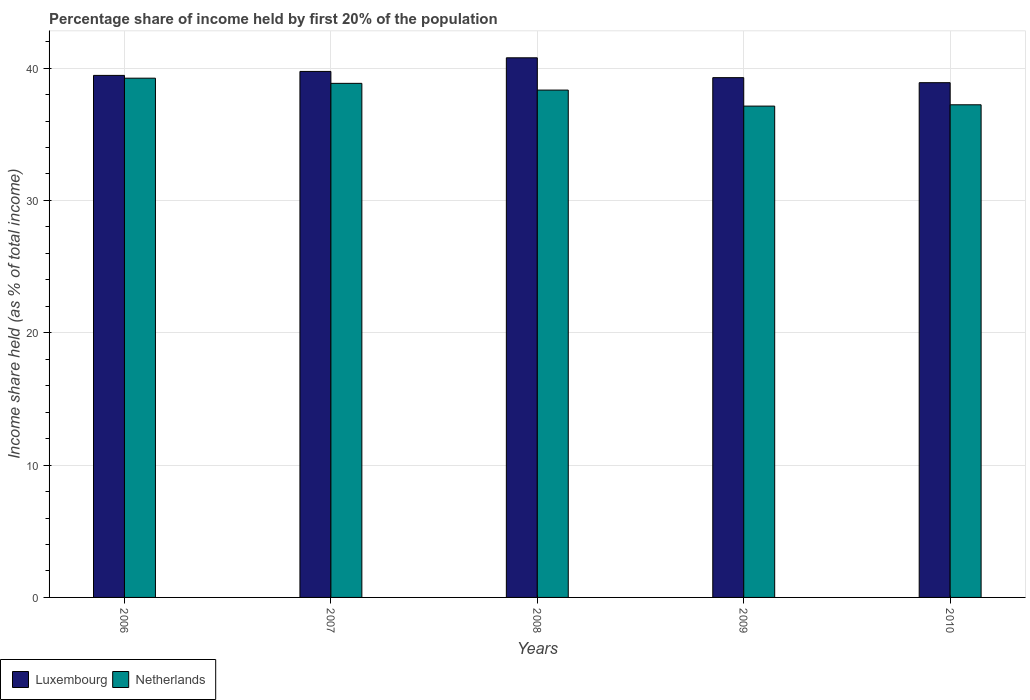How many groups of bars are there?
Provide a short and direct response. 5. Are the number of bars on each tick of the X-axis equal?
Ensure brevity in your answer.  Yes. How many bars are there on the 2nd tick from the left?
Ensure brevity in your answer.  2. What is the label of the 1st group of bars from the left?
Offer a very short reply. 2006. What is the share of income held by first 20% of the population in Luxembourg in 2008?
Your response must be concise. 40.78. Across all years, what is the maximum share of income held by first 20% of the population in Netherlands?
Your answer should be very brief. 39.24. Across all years, what is the minimum share of income held by first 20% of the population in Netherlands?
Give a very brief answer. 37.13. In which year was the share of income held by first 20% of the population in Luxembourg maximum?
Ensure brevity in your answer.  2008. What is the total share of income held by first 20% of the population in Luxembourg in the graph?
Offer a terse response. 198.16. What is the difference between the share of income held by first 20% of the population in Luxembourg in 2008 and that in 2009?
Offer a very short reply. 1.5. What is the difference between the share of income held by first 20% of the population in Netherlands in 2007 and the share of income held by first 20% of the population in Luxembourg in 2008?
Provide a succinct answer. -1.93. What is the average share of income held by first 20% of the population in Netherlands per year?
Your response must be concise. 38.16. In the year 2009, what is the difference between the share of income held by first 20% of the population in Luxembourg and share of income held by first 20% of the population in Netherlands?
Provide a succinct answer. 2.15. In how many years, is the share of income held by first 20% of the population in Netherlands greater than 18 %?
Provide a succinct answer. 5. What is the ratio of the share of income held by first 20% of the population in Netherlands in 2006 to that in 2010?
Provide a succinct answer. 1.05. Is the difference between the share of income held by first 20% of the population in Luxembourg in 2006 and 2008 greater than the difference between the share of income held by first 20% of the population in Netherlands in 2006 and 2008?
Your answer should be compact. No. What is the difference between the highest and the second highest share of income held by first 20% of the population in Netherlands?
Offer a terse response. 0.39. What is the difference between the highest and the lowest share of income held by first 20% of the population in Luxembourg?
Ensure brevity in your answer.  1.88. What does the 2nd bar from the right in 2009 represents?
Your answer should be very brief. Luxembourg. How many bars are there?
Provide a succinct answer. 10. Are all the bars in the graph horizontal?
Offer a terse response. No. Does the graph contain any zero values?
Offer a terse response. No. Where does the legend appear in the graph?
Give a very brief answer. Bottom left. How many legend labels are there?
Offer a terse response. 2. What is the title of the graph?
Give a very brief answer. Percentage share of income held by first 20% of the population. What is the label or title of the X-axis?
Ensure brevity in your answer.  Years. What is the label or title of the Y-axis?
Offer a very short reply. Income share held (as % of total income). What is the Income share held (as % of total income) of Luxembourg in 2006?
Your response must be concise. 39.45. What is the Income share held (as % of total income) in Netherlands in 2006?
Provide a succinct answer. 39.24. What is the Income share held (as % of total income) in Luxembourg in 2007?
Your answer should be very brief. 39.75. What is the Income share held (as % of total income) in Netherlands in 2007?
Offer a very short reply. 38.85. What is the Income share held (as % of total income) of Luxembourg in 2008?
Offer a very short reply. 40.78. What is the Income share held (as % of total income) of Netherlands in 2008?
Offer a very short reply. 38.34. What is the Income share held (as % of total income) in Luxembourg in 2009?
Provide a short and direct response. 39.28. What is the Income share held (as % of total income) in Netherlands in 2009?
Provide a succinct answer. 37.13. What is the Income share held (as % of total income) in Luxembourg in 2010?
Offer a terse response. 38.9. What is the Income share held (as % of total income) in Netherlands in 2010?
Offer a very short reply. 37.23. Across all years, what is the maximum Income share held (as % of total income) in Luxembourg?
Your answer should be compact. 40.78. Across all years, what is the maximum Income share held (as % of total income) in Netherlands?
Your answer should be very brief. 39.24. Across all years, what is the minimum Income share held (as % of total income) in Luxembourg?
Your response must be concise. 38.9. Across all years, what is the minimum Income share held (as % of total income) in Netherlands?
Offer a terse response. 37.13. What is the total Income share held (as % of total income) of Luxembourg in the graph?
Provide a succinct answer. 198.16. What is the total Income share held (as % of total income) of Netherlands in the graph?
Provide a short and direct response. 190.79. What is the difference between the Income share held (as % of total income) in Netherlands in 2006 and that in 2007?
Give a very brief answer. 0.39. What is the difference between the Income share held (as % of total income) of Luxembourg in 2006 and that in 2008?
Your response must be concise. -1.33. What is the difference between the Income share held (as % of total income) of Luxembourg in 2006 and that in 2009?
Offer a very short reply. 0.17. What is the difference between the Income share held (as % of total income) of Netherlands in 2006 and that in 2009?
Provide a succinct answer. 2.11. What is the difference between the Income share held (as % of total income) in Luxembourg in 2006 and that in 2010?
Your answer should be very brief. 0.55. What is the difference between the Income share held (as % of total income) in Netherlands in 2006 and that in 2010?
Your response must be concise. 2.01. What is the difference between the Income share held (as % of total income) of Luxembourg in 2007 and that in 2008?
Your answer should be very brief. -1.03. What is the difference between the Income share held (as % of total income) in Netherlands in 2007 and that in 2008?
Provide a succinct answer. 0.51. What is the difference between the Income share held (as % of total income) in Luxembourg in 2007 and that in 2009?
Ensure brevity in your answer.  0.47. What is the difference between the Income share held (as % of total income) of Netherlands in 2007 and that in 2009?
Provide a succinct answer. 1.72. What is the difference between the Income share held (as % of total income) of Luxembourg in 2007 and that in 2010?
Make the answer very short. 0.85. What is the difference between the Income share held (as % of total income) of Netherlands in 2007 and that in 2010?
Your answer should be very brief. 1.62. What is the difference between the Income share held (as % of total income) of Luxembourg in 2008 and that in 2009?
Give a very brief answer. 1.5. What is the difference between the Income share held (as % of total income) of Netherlands in 2008 and that in 2009?
Your answer should be compact. 1.21. What is the difference between the Income share held (as % of total income) of Luxembourg in 2008 and that in 2010?
Keep it short and to the point. 1.88. What is the difference between the Income share held (as % of total income) of Netherlands in 2008 and that in 2010?
Give a very brief answer. 1.11. What is the difference between the Income share held (as % of total income) of Luxembourg in 2009 and that in 2010?
Provide a succinct answer. 0.38. What is the difference between the Income share held (as % of total income) of Netherlands in 2009 and that in 2010?
Give a very brief answer. -0.1. What is the difference between the Income share held (as % of total income) of Luxembourg in 2006 and the Income share held (as % of total income) of Netherlands in 2008?
Keep it short and to the point. 1.11. What is the difference between the Income share held (as % of total income) of Luxembourg in 2006 and the Income share held (as % of total income) of Netherlands in 2009?
Keep it short and to the point. 2.32. What is the difference between the Income share held (as % of total income) of Luxembourg in 2006 and the Income share held (as % of total income) of Netherlands in 2010?
Your answer should be very brief. 2.22. What is the difference between the Income share held (as % of total income) of Luxembourg in 2007 and the Income share held (as % of total income) of Netherlands in 2008?
Give a very brief answer. 1.41. What is the difference between the Income share held (as % of total income) of Luxembourg in 2007 and the Income share held (as % of total income) of Netherlands in 2009?
Keep it short and to the point. 2.62. What is the difference between the Income share held (as % of total income) of Luxembourg in 2007 and the Income share held (as % of total income) of Netherlands in 2010?
Provide a short and direct response. 2.52. What is the difference between the Income share held (as % of total income) in Luxembourg in 2008 and the Income share held (as % of total income) in Netherlands in 2009?
Your answer should be compact. 3.65. What is the difference between the Income share held (as % of total income) of Luxembourg in 2008 and the Income share held (as % of total income) of Netherlands in 2010?
Keep it short and to the point. 3.55. What is the difference between the Income share held (as % of total income) in Luxembourg in 2009 and the Income share held (as % of total income) in Netherlands in 2010?
Offer a terse response. 2.05. What is the average Income share held (as % of total income) in Luxembourg per year?
Your answer should be compact. 39.63. What is the average Income share held (as % of total income) of Netherlands per year?
Provide a short and direct response. 38.16. In the year 2006, what is the difference between the Income share held (as % of total income) of Luxembourg and Income share held (as % of total income) of Netherlands?
Your answer should be very brief. 0.21. In the year 2007, what is the difference between the Income share held (as % of total income) of Luxembourg and Income share held (as % of total income) of Netherlands?
Offer a very short reply. 0.9. In the year 2008, what is the difference between the Income share held (as % of total income) in Luxembourg and Income share held (as % of total income) in Netherlands?
Make the answer very short. 2.44. In the year 2009, what is the difference between the Income share held (as % of total income) in Luxembourg and Income share held (as % of total income) in Netherlands?
Your answer should be compact. 2.15. In the year 2010, what is the difference between the Income share held (as % of total income) in Luxembourg and Income share held (as % of total income) in Netherlands?
Provide a short and direct response. 1.67. What is the ratio of the Income share held (as % of total income) in Netherlands in 2006 to that in 2007?
Offer a terse response. 1.01. What is the ratio of the Income share held (as % of total income) in Luxembourg in 2006 to that in 2008?
Give a very brief answer. 0.97. What is the ratio of the Income share held (as % of total income) of Netherlands in 2006 to that in 2008?
Ensure brevity in your answer.  1.02. What is the ratio of the Income share held (as % of total income) of Netherlands in 2006 to that in 2009?
Offer a very short reply. 1.06. What is the ratio of the Income share held (as % of total income) in Luxembourg in 2006 to that in 2010?
Provide a succinct answer. 1.01. What is the ratio of the Income share held (as % of total income) of Netherlands in 2006 to that in 2010?
Offer a very short reply. 1.05. What is the ratio of the Income share held (as % of total income) of Luxembourg in 2007 to that in 2008?
Provide a succinct answer. 0.97. What is the ratio of the Income share held (as % of total income) of Netherlands in 2007 to that in 2008?
Your answer should be compact. 1.01. What is the ratio of the Income share held (as % of total income) in Luxembourg in 2007 to that in 2009?
Provide a succinct answer. 1.01. What is the ratio of the Income share held (as % of total income) in Netherlands in 2007 to that in 2009?
Provide a short and direct response. 1.05. What is the ratio of the Income share held (as % of total income) of Luxembourg in 2007 to that in 2010?
Give a very brief answer. 1.02. What is the ratio of the Income share held (as % of total income) in Netherlands in 2007 to that in 2010?
Make the answer very short. 1.04. What is the ratio of the Income share held (as % of total income) in Luxembourg in 2008 to that in 2009?
Ensure brevity in your answer.  1.04. What is the ratio of the Income share held (as % of total income) of Netherlands in 2008 to that in 2009?
Your answer should be very brief. 1.03. What is the ratio of the Income share held (as % of total income) of Luxembourg in 2008 to that in 2010?
Your answer should be very brief. 1.05. What is the ratio of the Income share held (as % of total income) of Netherlands in 2008 to that in 2010?
Your answer should be compact. 1.03. What is the ratio of the Income share held (as % of total income) in Luxembourg in 2009 to that in 2010?
Your answer should be very brief. 1.01. What is the difference between the highest and the second highest Income share held (as % of total income) of Netherlands?
Provide a succinct answer. 0.39. What is the difference between the highest and the lowest Income share held (as % of total income) in Luxembourg?
Your answer should be very brief. 1.88. What is the difference between the highest and the lowest Income share held (as % of total income) in Netherlands?
Give a very brief answer. 2.11. 